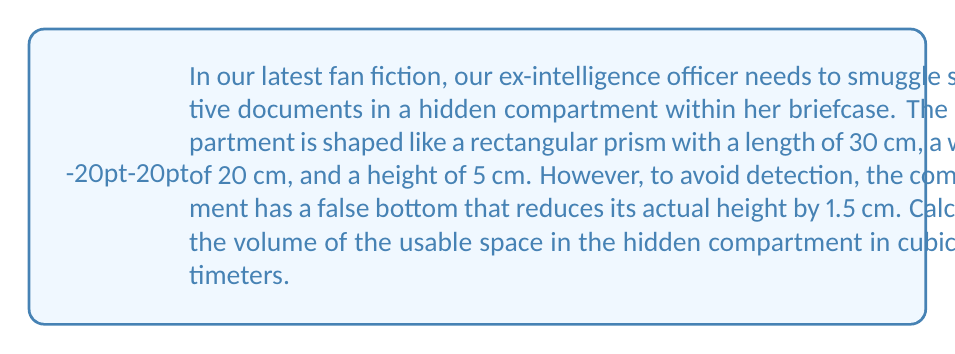Give your solution to this math problem. To solve this problem, we need to follow these steps:

1. Identify the dimensions of the compartment:
   Length (l) = 30 cm
   Width (w) = 20 cm
   Original height (h) = 5 cm
   False bottom thickness = 1.5 cm

2. Calculate the actual usable height:
   Actual height = Original height - False bottom thickness
   $h_{actual} = 5 \text{ cm} - 1.5 \text{ cm} = 3.5 \text{ cm}$

3. Use the formula for the volume of a rectangular prism:
   $$V = l \times w \times h$$

4. Substitute the values into the formula:
   $$V = 30 \text{ cm} \times 20 \text{ cm} \times 3.5 \text{ cm}$$

5. Perform the multiplication:
   $$V = 2100 \text{ cm}^3$$

Therefore, the volume of the usable space in the hidden compartment is 2100 cubic centimeters.
Answer: $2100 \text{ cm}^3$ 